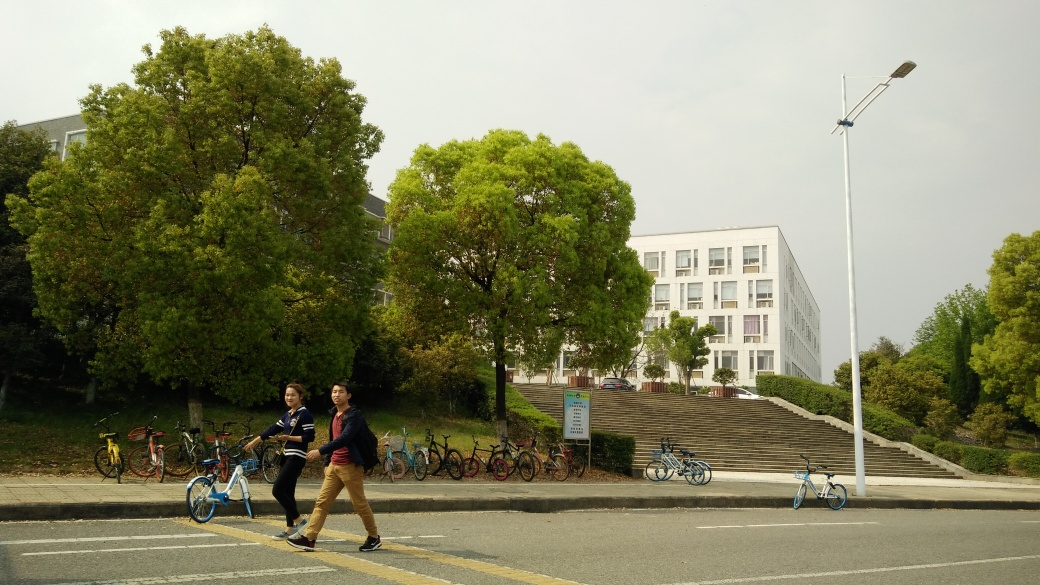Are there any notable colors or themes in this image? The overall color palette is quite natural and earthy, with predominant shades of green from the trees and a muted gray from the overcast sky and urban structures. The theme could be interpreted as a harmony between urban life and nature, with a clear human presence in an environment that maintains a balance with natural elements like trees. 